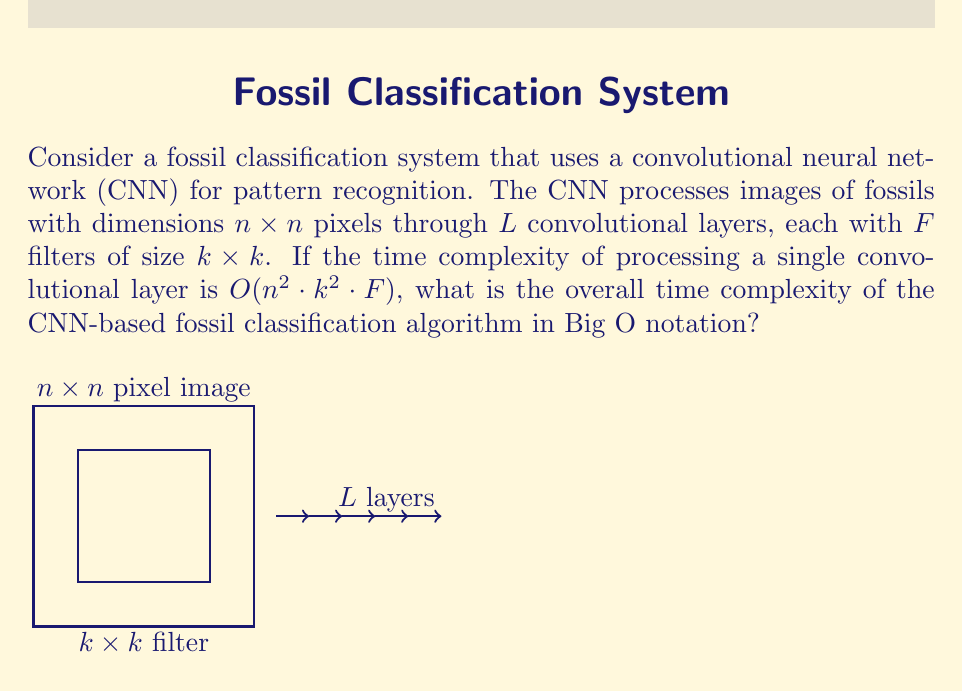Teach me how to tackle this problem. To determine the overall time complexity, we need to consider the following steps:

1) First, recall that the time complexity for processing a single convolutional layer is given as $O(n^2 \cdot k^2 \cdot F)$.

2) The CNN processes the image through $L$ convolutional layers. This means we need to multiply the complexity of a single layer by $L$.

3) The time complexity for all layers becomes:

   $O(L \cdot n^2 \cdot k^2 \cdot F)$

4) In Big O notation, we typically express the complexity in terms of the input size. In this case, the input size is represented by $n$ (the dimensions of the image).

5) The parameters $L$ (number of layers), $k$ (filter size), and $F$ (number of filters) are usually fixed for a given CNN architecture and don't grow with the input size.

6) Therefore, we can treat $L$, $k$, and $F$ as constants in our Big O expression.

7) When we have constants in Big O notation, we can drop them as they don't affect the growth rate of the function. This leaves us with:

   $O(n^2)$

This represents the quadratic time complexity of the CNN-based fossil classification algorithm in terms of the input image size.
Answer: $O(n^2)$ 